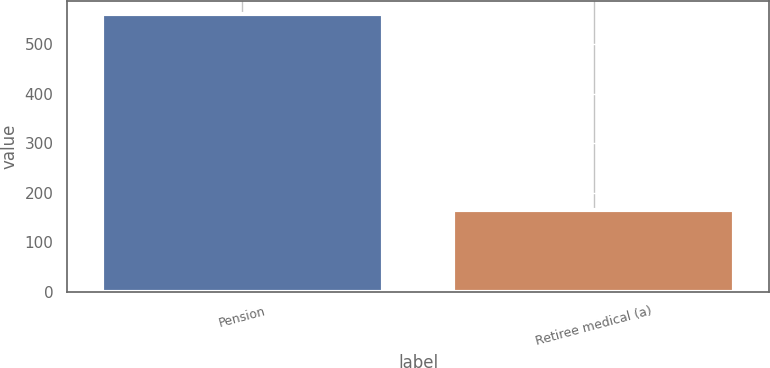Convert chart to OTSL. <chart><loc_0><loc_0><loc_500><loc_500><bar_chart><fcel>Pension<fcel>Retiree medical (a)<nl><fcel>560<fcel>165<nl></chart> 